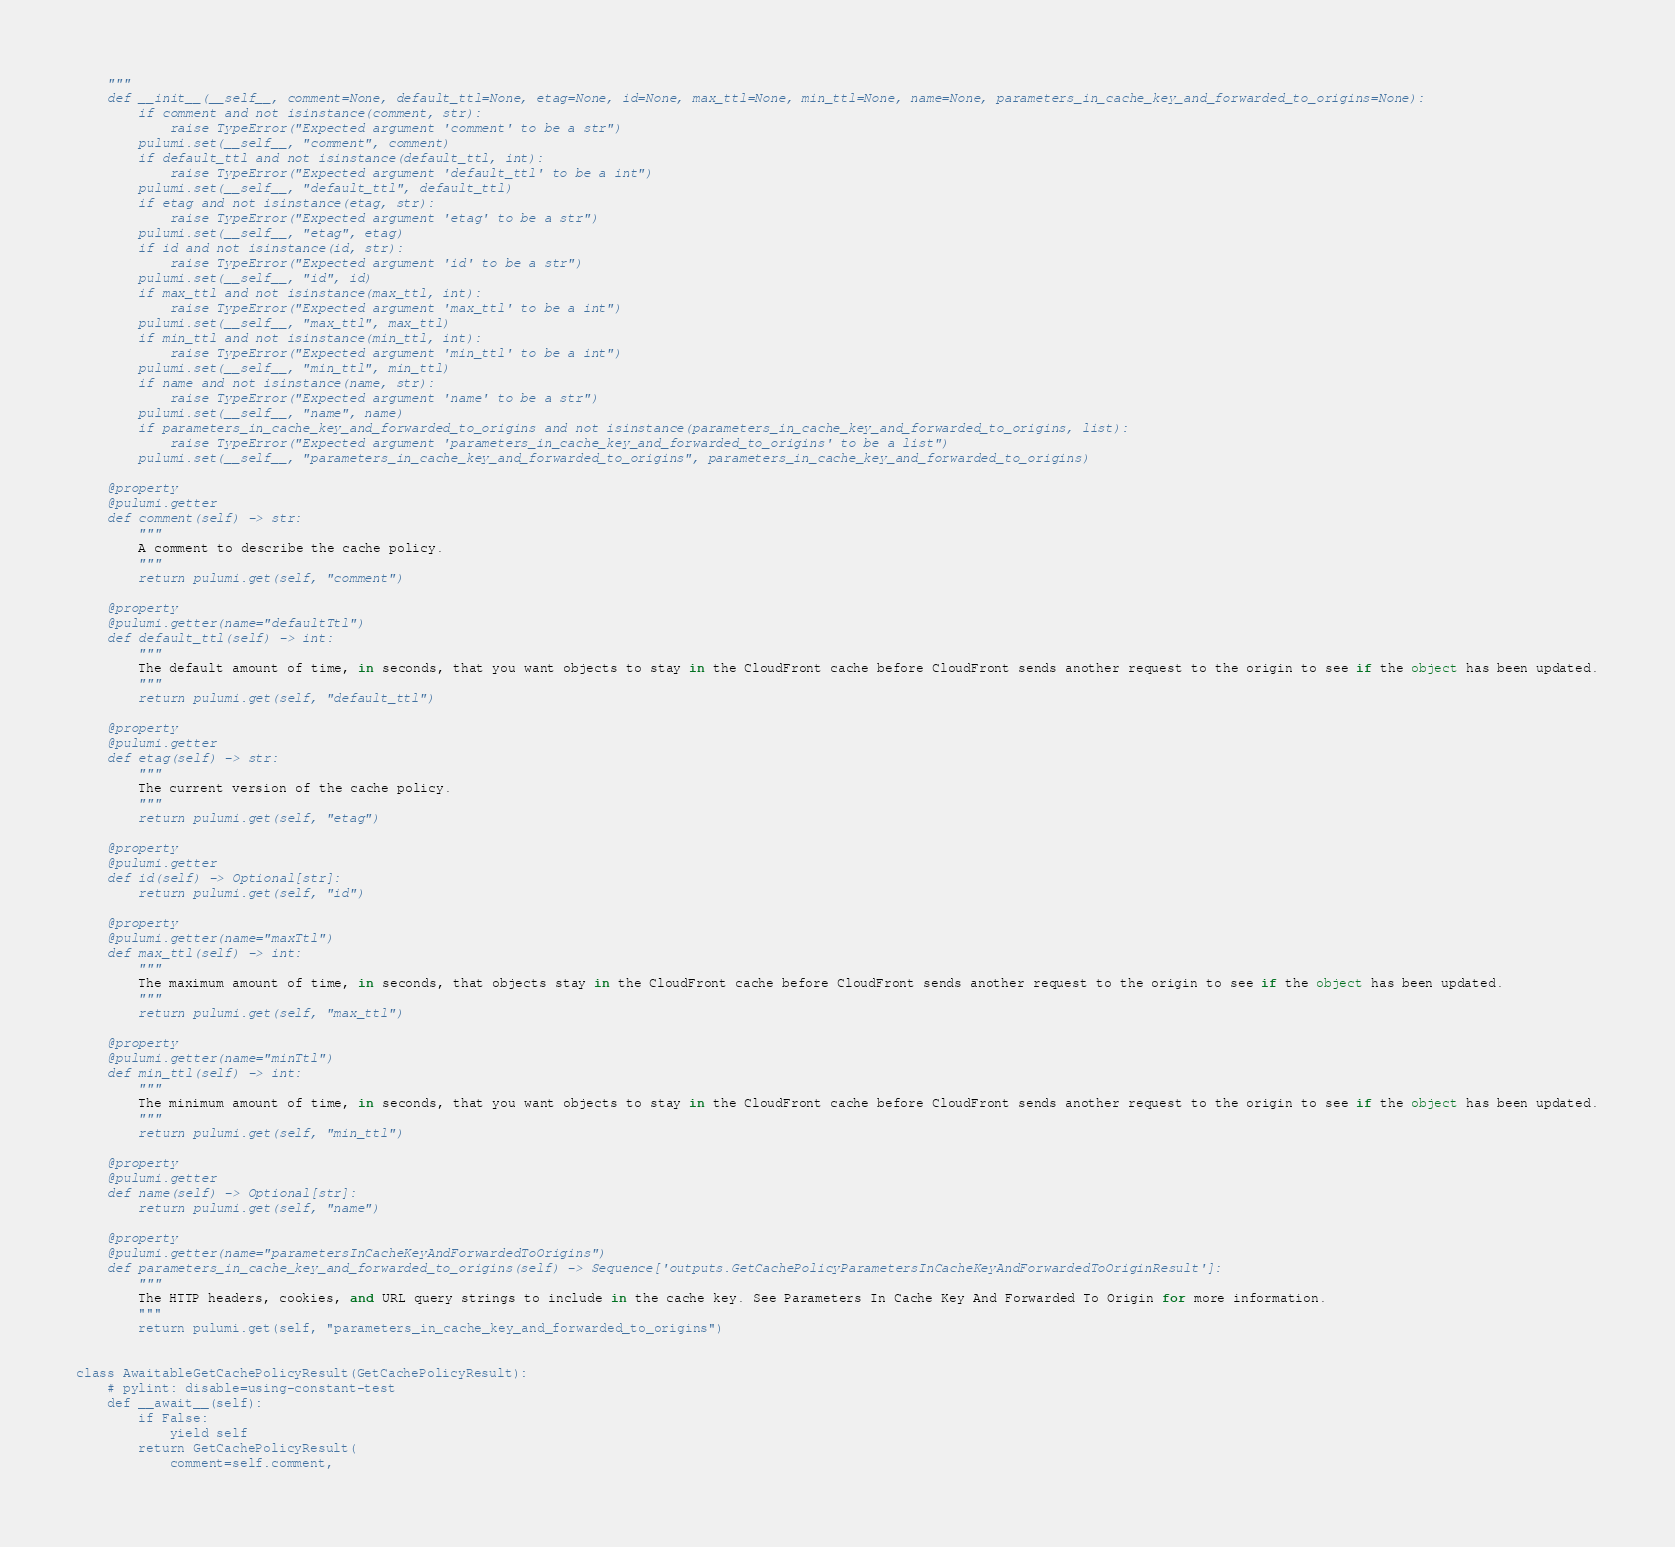<code> <loc_0><loc_0><loc_500><loc_500><_Python_>    """
    def __init__(__self__, comment=None, default_ttl=None, etag=None, id=None, max_ttl=None, min_ttl=None, name=None, parameters_in_cache_key_and_forwarded_to_origins=None):
        if comment and not isinstance(comment, str):
            raise TypeError("Expected argument 'comment' to be a str")
        pulumi.set(__self__, "comment", comment)
        if default_ttl and not isinstance(default_ttl, int):
            raise TypeError("Expected argument 'default_ttl' to be a int")
        pulumi.set(__self__, "default_ttl", default_ttl)
        if etag and not isinstance(etag, str):
            raise TypeError("Expected argument 'etag' to be a str")
        pulumi.set(__self__, "etag", etag)
        if id and not isinstance(id, str):
            raise TypeError("Expected argument 'id' to be a str")
        pulumi.set(__self__, "id", id)
        if max_ttl and not isinstance(max_ttl, int):
            raise TypeError("Expected argument 'max_ttl' to be a int")
        pulumi.set(__self__, "max_ttl", max_ttl)
        if min_ttl and not isinstance(min_ttl, int):
            raise TypeError("Expected argument 'min_ttl' to be a int")
        pulumi.set(__self__, "min_ttl", min_ttl)
        if name and not isinstance(name, str):
            raise TypeError("Expected argument 'name' to be a str")
        pulumi.set(__self__, "name", name)
        if parameters_in_cache_key_and_forwarded_to_origins and not isinstance(parameters_in_cache_key_and_forwarded_to_origins, list):
            raise TypeError("Expected argument 'parameters_in_cache_key_and_forwarded_to_origins' to be a list")
        pulumi.set(__self__, "parameters_in_cache_key_and_forwarded_to_origins", parameters_in_cache_key_and_forwarded_to_origins)

    @property
    @pulumi.getter
    def comment(self) -> str:
        """
        A comment to describe the cache policy.
        """
        return pulumi.get(self, "comment")

    @property
    @pulumi.getter(name="defaultTtl")
    def default_ttl(self) -> int:
        """
        The default amount of time, in seconds, that you want objects to stay in the CloudFront cache before CloudFront sends another request to the origin to see if the object has been updated.
        """
        return pulumi.get(self, "default_ttl")

    @property
    @pulumi.getter
    def etag(self) -> str:
        """
        The current version of the cache policy.
        """
        return pulumi.get(self, "etag")

    @property
    @pulumi.getter
    def id(self) -> Optional[str]:
        return pulumi.get(self, "id")

    @property
    @pulumi.getter(name="maxTtl")
    def max_ttl(self) -> int:
        """
        The maximum amount of time, in seconds, that objects stay in the CloudFront cache before CloudFront sends another request to the origin to see if the object has been updated.
        """
        return pulumi.get(self, "max_ttl")

    @property
    @pulumi.getter(name="minTtl")
    def min_ttl(self) -> int:
        """
        The minimum amount of time, in seconds, that you want objects to stay in the CloudFront cache before CloudFront sends another request to the origin to see if the object has been updated.
        """
        return pulumi.get(self, "min_ttl")

    @property
    @pulumi.getter
    def name(self) -> Optional[str]:
        return pulumi.get(self, "name")

    @property
    @pulumi.getter(name="parametersInCacheKeyAndForwardedToOrigins")
    def parameters_in_cache_key_and_forwarded_to_origins(self) -> Sequence['outputs.GetCachePolicyParametersInCacheKeyAndForwardedToOriginResult']:
        """
        The HTTP headers, cookies, and URL query strings to include in the cache key. See Parameters In Cache Key And Forwarded To Origin for more information.
        """
        return pulumi.get(self, "parameters_in_cache_key_and_forwarded_to_origins")


class AwaitableGetCachePolicyResult(GetCachePolicyResult):
    # pylint: disable=using-constant-test
    def __await__(self):
        if False:
            yield self
        return GetCachePolicyResult(
            comment=self.comment,</code> 